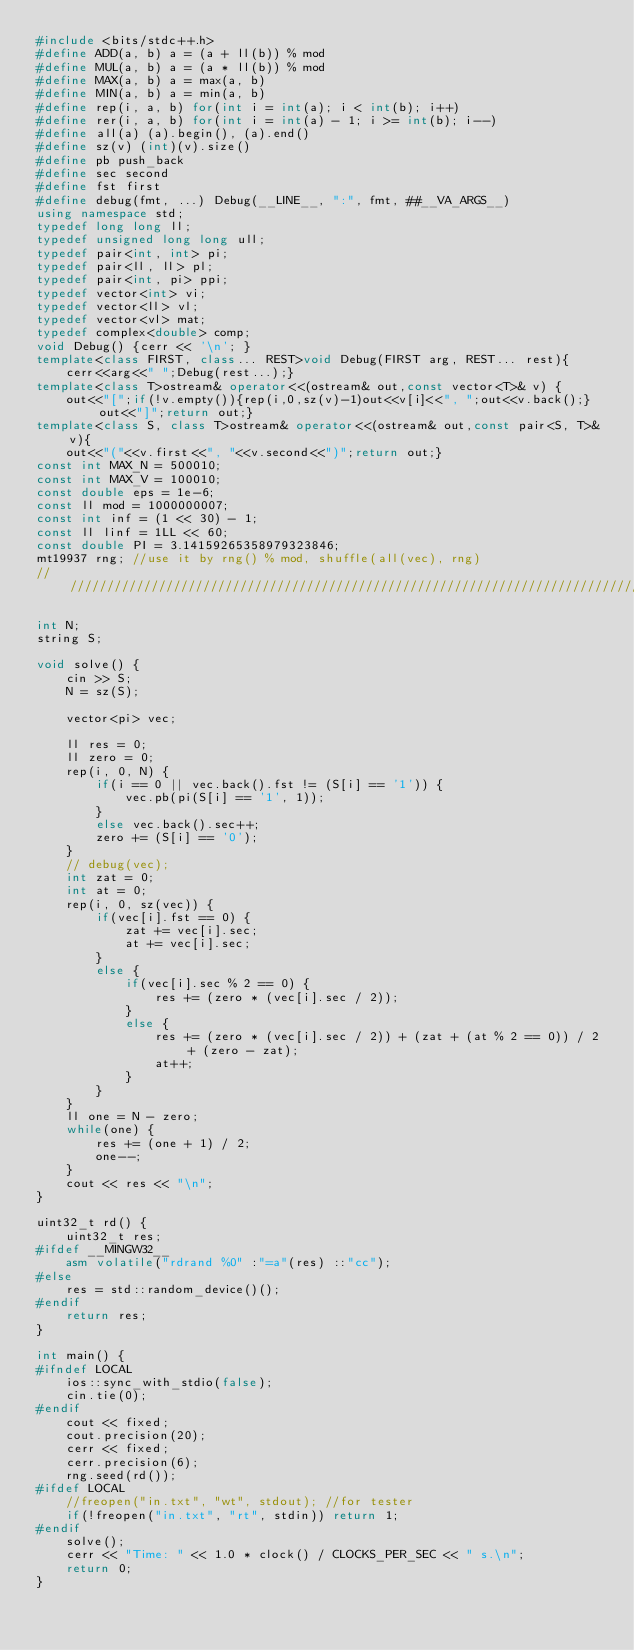Convert code to text. <code><loc_0><loc_0><loc_500><loc_500><_C++_>#include <bits/stdc++.h>
#define ADD(a, b) a = (a + ll(b)) % mod
#define MUL(a, b) a = (a * ll(b)) % mod
#define MAX(a, b) a = max(a, b)
#define MIN(a, b) a = min(a, b)
#define rep(i, a, b) for(int i = int(a); i < int(b); i++)
#define rer(i, a, b) for(int i = int(a) - 1; i >= int(b); i--)
#define all(a) (a).begin(), (a).end()
#define sz(v) (int)(v).size()
#define pb push_back
#define sec second
#define fst first
#define debug(fmt, ...) Debug(__LINE__, ":", fmt, ##__VA_ARGS__)
using namespace std;
typedef long long ll;
typedef unsigned long long ull;
typedef pair<int, int> pi;
typedef pair<ll, ll> pl;
typedef pair<int, pi> ppi;
typedef vector<int> vi;
typedef vector<ll> vl;
typedef vector<vl> mat;
typedef complex<double> comp;
void Debug() {cerr << '\n'; }
template<class FIRST, class... REST>void Debug(FIRST arg, REST... rest){
	cerr<<arg<<" ";Debug(rest...);}
template<class T>ostream& operator<<(ostream& out,const vector<T>& v) {
	out<<"[";if(!v.empty()){rep(i,0,sz(v)-1)out<<v[i]<<", ";out<<v.back();}out<<"]";return out;}
template<class S, class T>ostream& operator<<(ostream& out,const pair<S, T>& v){
	out<<"("<<v.first<<", "<<v.second<<")";return out;}
const int MAX_N = 500010;
const int MAX_V = 100010;
const double eps = 1e-6;
const ll mod = 1000000007;
const int inf = (1 << 30) - 1;
const ll linf = 1LL << 60;
const double PI = 3.14159265358979323846;
mt19937 rng; //use it by rng() % mod, shuffle(all(vec), rng)
///////////////////////////////////////////////////////////////////////////////////////////////////

int N;
string S;

void solve() {
	cin >> S;
	N = sz(S);

	vector<pi> vec;

	ll res = 0;
	ll zero = 0;
	rep(i, 0, N) {
		if(i == 0 || vec.back().fst != (S[i] == '1')) {
			vec.pb(pi(S[i] == '1', 1));
		}
		else vec.back().sec++;
		zero += (S[i] == '0');
	}
	// debug(vec);
	int zat = 0;
	int at = 0;
	rep(i, 0, sz(vec)) {
		if(vec[i].fst == 0) {
			zat += vec[i].sec;
			at += vec[i].sec;
		}
		else {
			if(vec[i].sec % 2 == 0) {
				res += (zero * (vec[i].sec / 2));
			}
			else {
				res += (zero * (vec[i].sec / 2)) + (zat + (at % 2 == 0)) / 2 + (zero - zat);
				at++;
			}
		}
	}
	ll one = N - zero;
	while(one) {
		res += (one + 1) / 2;
		one--;
	}
	cout << res << "\n";
}

uint32_t rd() {
	uint32_t res;
#ifdef __MINGW32__
	asm volatile("rdrand %0" :"=a"(res) ::"cc");
#else
	res = std::random_device()();
#endif
	return res;
}

int main() {
#ifndef LOCAL
	ios::sync_with_stdio(false);
    cin.tie(0);
#endif
    cout << fixed;
	cout.precision(20);
    cerr << fixed;
	cerr.precision(6);
	rng.seed(rd());
#ifdef LOCAL
	//freopen("in.txt", "wt", stdout); //for tester
	if(!freopen("in.txt", "rt", stdin)) return 1;
#endif	
	solve();
    cerr << "Time: " << 1.0 * clock() / CLOCKS_PER_SEC << " s.\n";
	return 0;
}

</code> 